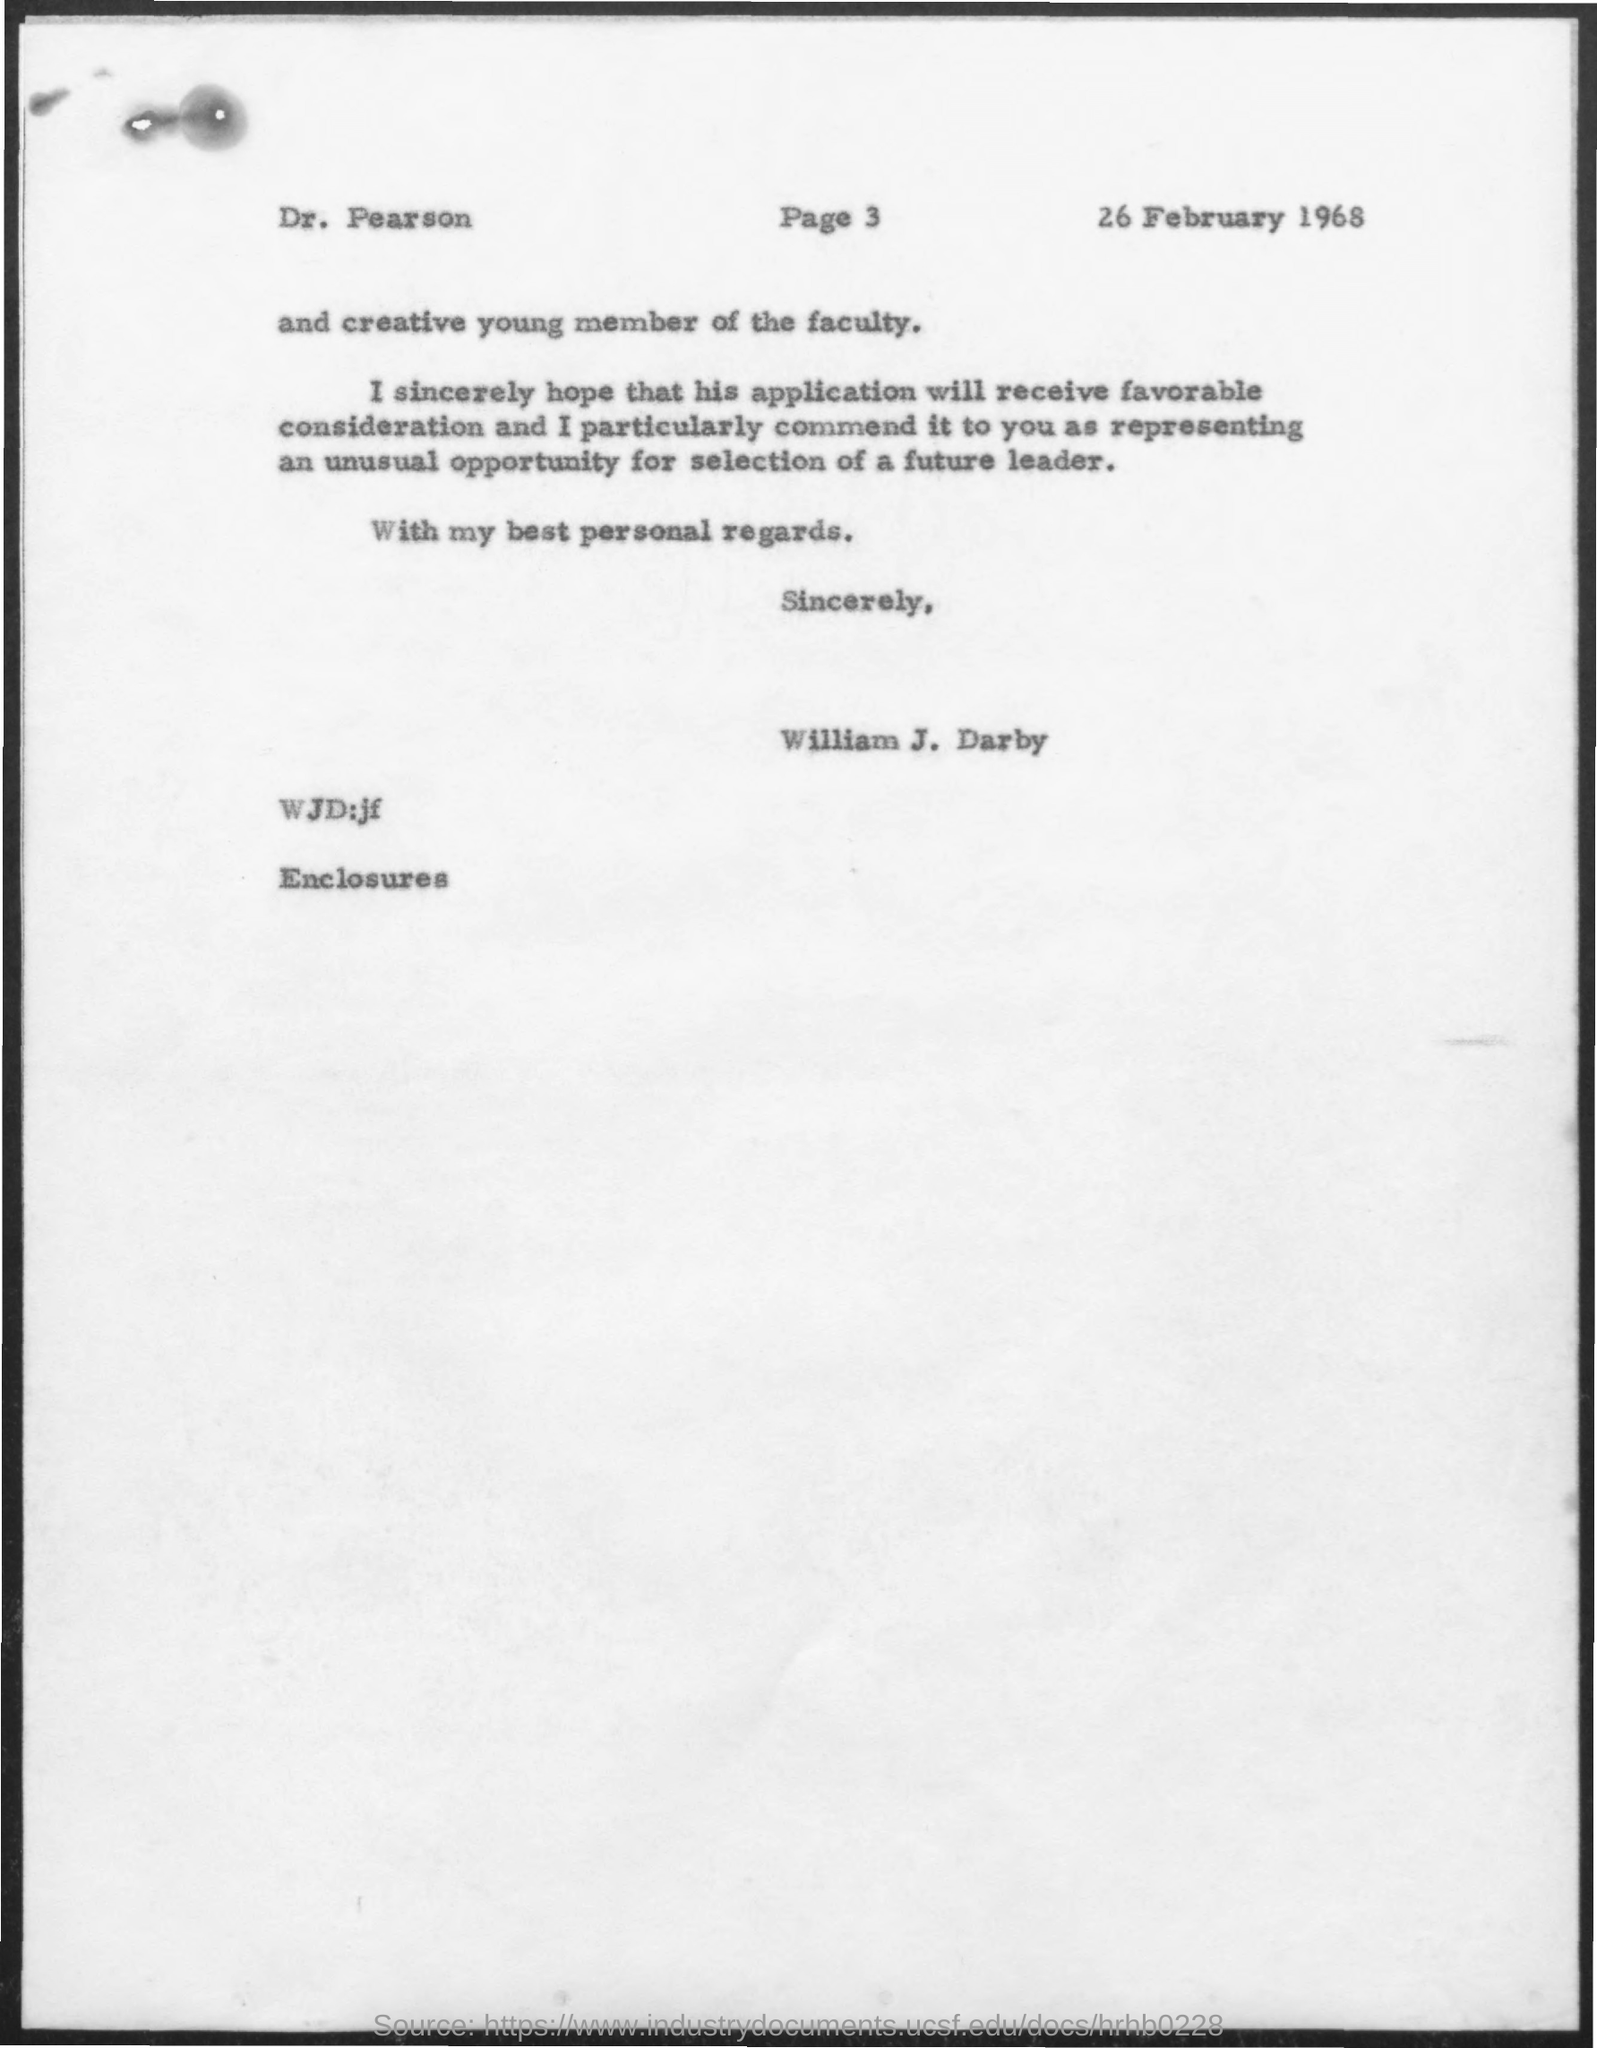Identify some key points in this picture. The date mentioned in the given page is February 26, 1968. 